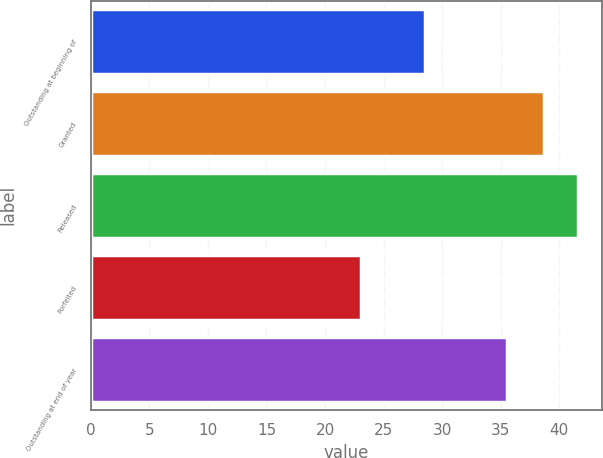<chart> <loc_0><loc_0><loc_500><loc_500><bar_chart><fcel>Outstanding at beginning of<fcel>Granted<fcel>Released<fcel>Forfeited<fcel>Outstanding at end of year<nl><fcel>28.58<fcel>38.68<fcel>41.57<fcel>23.06<fcel>35.55<nl></chart> 